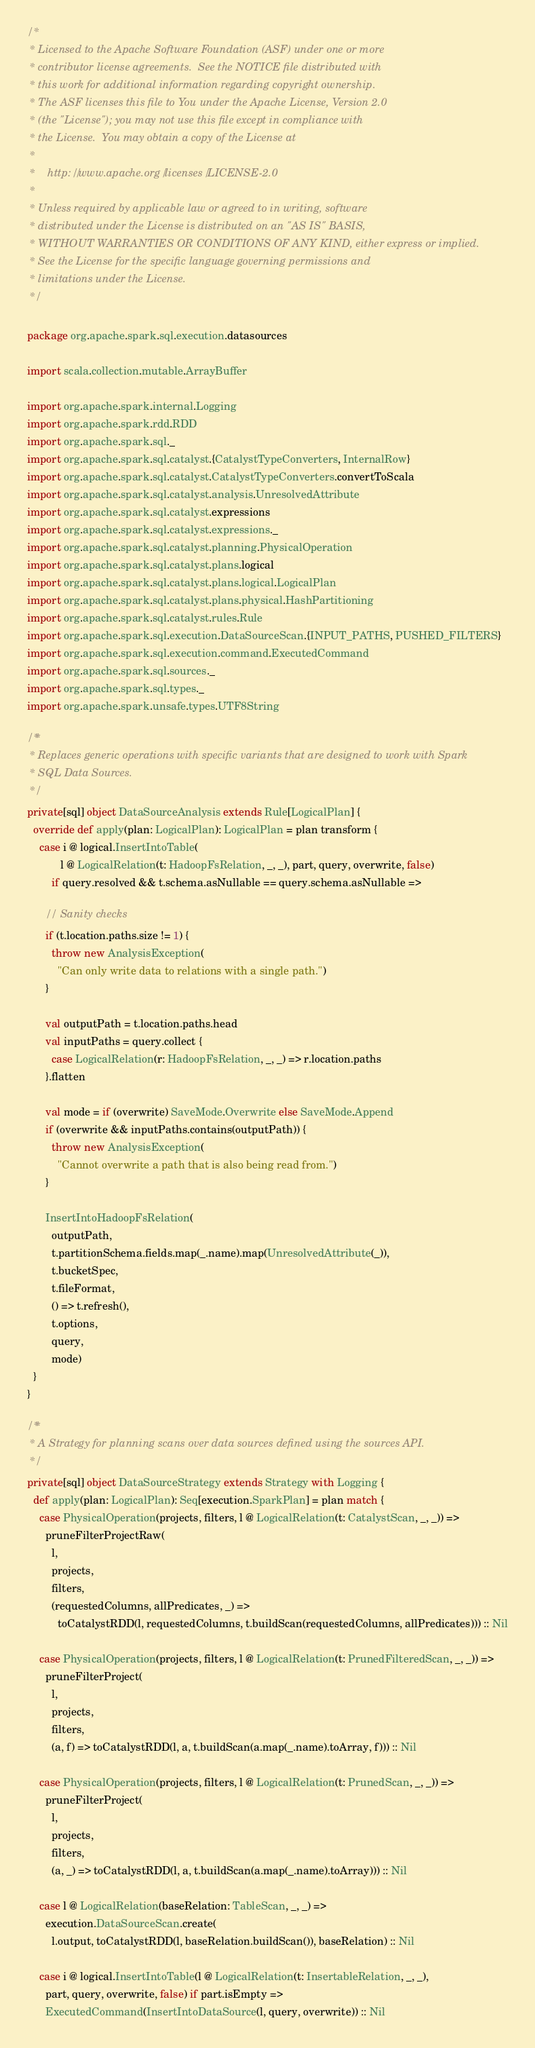<code> <loc_0><loc_0><loc_500><loc_500><_Scala_>/*
 * Licensed to the Apache Software Foundation (ASF) under one or more
 * contributor license agreements.  See the NOTICE file distributed with
 * this work for additional information regarding copyright ownership.
 * The ASF licenses this file to You under the Apache License, Version 2.0
 * (the "License"); you may not use this file except in compliance with
 * the License.  You may obtain a copy of the License at
 *
 *    http://www.apache.org/licenses/LICENSE-2.0
 *
 * Unless required by applicable law or agreed to in writing, software
 * distributed under the License is distributed on an "AS IS" BASIS,
 * WITHOUT WARRANTIES OR CONDITIONS OF ANY KIND, either express or implied.
 * See the License for the specific language governing permissions and
 * limitations under the License.
 */

package org.apache.spark.sql.execution.datasources

import scala.collection.mutable.ArrayBuffer

import org.apache.spark.internal.Logging
import org.apache.spark.rdd.RDD
import org.apache.spark.sql._
import org.apache.spark.sql.catalyst.{CatalystTypeConverters, InternalRow}
import org.apache.spark.sql.catalyst.CatalystTypeConverters.convertToScala
import org.apache.spark.sql.catalyst.analysis.UnresolvedAttribute
import org.apache.spark.sql.catalyst.expressions
import org.apache.spark.sql.catalyst.expressions._
import org.apache.spark.sql.catalyst.planning.PhysicalOperation
import org.apache.spark.sql.catalyst.plans.logical
import org.apache.spark.sql.catalyst.plans.logical.LogicalPlan
import org.apache.spark.sql.catalyst.plans.physical.HashPartitioning
import org.apache.spark.sql.catalyst.rules.Rule
import org.apache.spark.sql.execution.DataSourceScan.{INPUT_PATHS, PUSHED_FILTERS}
import org.apache.spark.sql.execution.command.ExecutedCommand
import org.apache.spark.sql.sources._
import org.apache.spark.sql.types._
import org.apache.spark.unsafe.types.UTF8String

/**
 * Replaces generic operations with specific variants that are designed to work with Spark
 * SQL Data Sources.
 */
private[sql] object DataSourceAnalysis extends Rule[LogicalPlan] {
  override def apply(plan: LogicalPlan): LogicalPlan = plan transform {
    case i @ logical.InsertIntoTable(
           l @ LogicalRelation(t: HadoopFsRelation, _, _), part, query, overwrite, false)
        if query.resolved && t.schema.asNullable == query.schema.asNullable =>

      // Sanity checks
      if (t.location.paths.size != 1) {
        throw new AnalysisException(
          "Can only write data to relations with a single path.")
      }

      val outputPath = t.location.paths.head
      val inputPaths = query.collect {
        case LogicalRelation(r: HadoopFsRelation, _, _) => r.location.paths
      }.flatten

      val mode = if (overwrite) SaveMode.Overwrite else SaveMode.Append
      if (overwrite && inputPaths.contains(outputPath)) {
        throw new AnalysisException(
          "Cannot overwrite a path that is also being read from.")
      }

      InsertIntoHadoopFsRelation(
        outputPath,
        t.partitionSchema.fields.map(_.name).map(UnresolvedAttribute(_)),
        t.bucketSpec,
        t.fileFormat,
        () => t.refresh(),
        t.options,
        query,
        mode)
  }
}

/**
 * A Strategy for planning scans over data sources defined using the sources API.
 */
private[sql] object DataSourceStrategy extends Strategy with Logging {
  def apply(plan: LogicalPlan): Seq[execution.SparkPlan] = plan match {
    case PhysicalOperation(projects, filters, l @ LogicalRelation(t: CatalystScan, _, _)) =>
      pruneFilterProjectRaw(
        l,
        projects,
        filters,
        (requestedColumns, allPredicates, _) =>
          toCatalystRDD(l, requestedColumns, t.buildScan(requestedColumns, allPredicates))) :: Nil

    case PhysicalOperation(projects, filters, l @ LogicalRelation(t: PrunedFilteredScan, _, _)) =>
      pruneFilterProject(
        l,
        projects,
        filters,
        (a, f) => toCatalystRDD(l, a, t.buildScan(a.map(_.name).toArray, f))) :: Nil

    case PhysicalOperation(projects, filters, l @ LogicalRelation(t: PrunedScan, _, _)) =>
      pruneFilterProject(
        l,
        projects,
        filters,
        (a, _) => toCatalystRDD(l, a, t.buildScan(a.map(_.name).toArray))) :: Nil

    case l @ LogicalRelation(baseRelation: TableScan, _, _) =>
      execution.DataSourceScan.create(
        l.output, toCatalystRDD(l, baseRelation.buildScan()), baseRelation) :: Nil

    case i @ logical.InsertIntoTable(l @ LogicalRelation(t: InsertableRelation, _, _),
      part, query, overwrite, false) if part.isEmpty =>
      ExecutedCommand(InsertIntoDataSource(l, query, overwrite)) :: Nil
</code> 